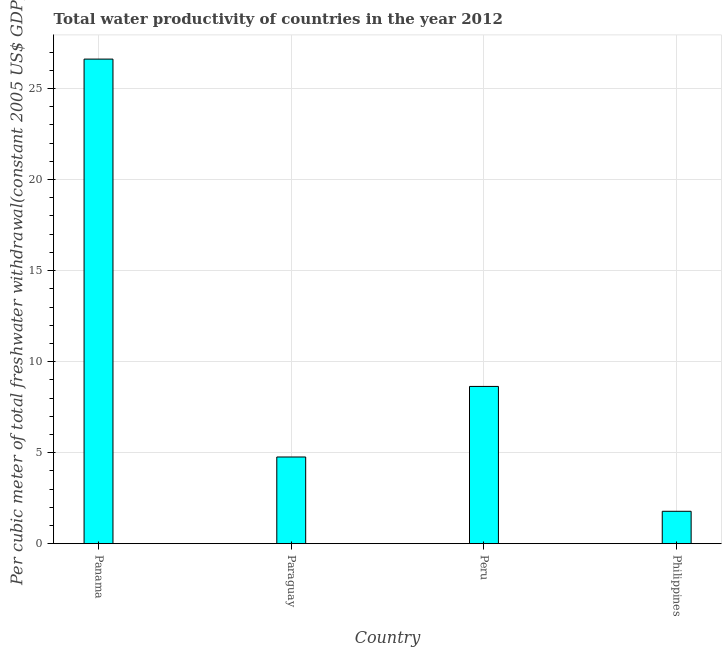What is the title of the graph?
Keep it short and to the point. Total water productivity of countries in the year 2012. What is the label or title of the Y-axis?
Give a very brief answer. Per cubic meter of total freshwater withdrawal(constant 2005 US$ GDP). What is the total water productivity in Panama?
Ensure brevity in your answer.  26.62. Across all countries, what is the maximum total water productivity?
Your answer should be very brief. 26.62. Across all countries, what is the minimum total water productivity?
Make the answer very short. 1.78. In which country was the total water productivity maximum?
Offer a terse response. Panama. What is the sum of the total water productivity?
Offer a very short reply. 41.79. What is the difference between the total water productivity in Peru and Philippines?
Make the answer very short. 6.86. What is the average total water productivity per country?
Ensure brevity in your answer.  10.45. What is the median total water productivity?
Provide a short and direct response. 6.7. In how many countries, is the total water productivity greater than 4 US$?
Make the answer very short. 3. What is the ratio of the total water productivity in Panama to that in Paraguay?
Keep it short and to the point. 5.59. What is the difference between the highest and the second highest total water productivity?
Your answer should be very brief. 17.98. What is the difference between the highest and the lowest total water productivity?
Your answer should be very brief. 24.84. In how many countries, is the total water productivity greater than the average total water productivity taken over all countries?
Provide a succinct answer. 1. Are all the bars in the graph horizontal?
Your answer should be very brief. No. How many countries are there in the graph?
Give a very brief answer. 4. What is the difference between two consecutive major ticks on the Y-axis?
Provide a succinct answer. 5. What is the Per cubic meter of total freshwater withdrawal(constant 2005 US$ GDP) of Panama?
Your response must be concise. 26.62. What is the Per cubic meter of total freshwater withdrawal(constant 2005 US$ GDP) of Paraguay?
Your response must be concise. 4.76. What is the Per cubic meter of total freshwater withdrawal(constant 2005 US$ GDP) of Peru?
Your answer should be very brief. 8.64. What is the Per cubic meter of total freshwater withdrawal(constant 2005 US$ GDP) in Philippines?
Your answer should be compact. 1.78. What is the difference between the Per cubic meter of total freshwater withdrawal(constant 2005 US$ GDP) in Panama and Paraguay?
Give a very brief answer. 21.86. What is the difference between the Per cubic meter of total freshwater withdrawal(constant 2005 US$ GDP) in Panama and Peru?
Ensure brevity in your answer.  17.98. What is the difference between the Per cubic meter of total freshwater withdrawal(constant 2005 US$ GDP) in Panama and Philippines?
Offer a terse response. 24.84. What is the difference between the Per cubic meter of total freshwater withdrawal(constant 2005 US$ GDP) in Paraguay and Peru?
Make the answer very short. -3.88. What is the difference between the Per cubic meter of total freshwater withdrawal(constant 2005 US$ GDP) in Paraguay and Philippines?
Make the answer very short. 2.98. What is the difference between the Per cubic meter of total freshwater withdrawal(constant 2005 US$ GDP) in Peru and Philippines?
Ensure brevity in your answer.  6.86. What is the ratio of the Per cubic meter of total freshwater withdrawal(constant 2005 US$ GDP) in Panama to that in Paraguay?
Ensure brevity in your answer.  5.59. What is the ratio of the Per cubic meter of total freshwater withdrawal(constant 2005 US$ GDP) in Panama to that in Peru?
Your answer should be very brief. 3.08. What is the ratio of the Per cubic meter of total freshwater withdrawal(constant 2005 US$ GDP) in Panama to that in Philippines?
Make the answer very short. 14.97. What is the ratio of the Per cubic meter of total freshwater withdrawal(constant 2005 US$ GDP) in Paraguay to that in Peru?
Keep it short and to the point. 0.55. What is the ratio of the Per cubic meter of total freshwater withdrawal(constant 2005 US$ GDP) in Paraguay to that in Philippines?
Ensure brevity in your answer.  2.68. What is the ratio of the Per cubic meter of total freshwater withdrawal(constant 2005 US$ GDP) in Peru to that in Philippines?
Provide a succinct answer. 4.86. 